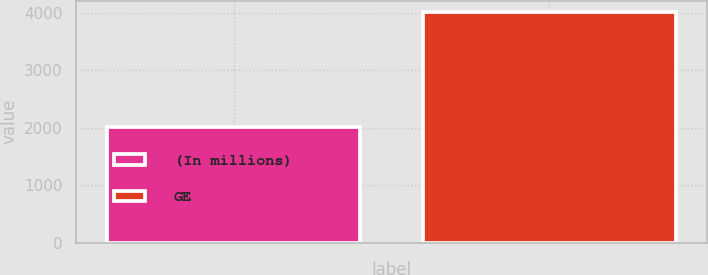<chart> <loc_0><loc_0><loc_500><loc_500><bar_chart><fcel>(In millions)<fcel>GE<nl><fcel>2017<fcel>4015<nl></chart> 